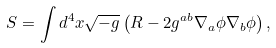Convert formula to latex. <formula><loc_0><loc_0><loc_500><loc_500>S = \int d ^ { 4 } x \sqrt { - g } \left ( R - 2 g ^ { a b } \nabla _ { a } \phi \nabla _ { b } \phi \right ) ,</formula> 